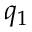<formula> <loc_0><loc_0><loc_500><loc_500>q _ { 1 }</formula> 